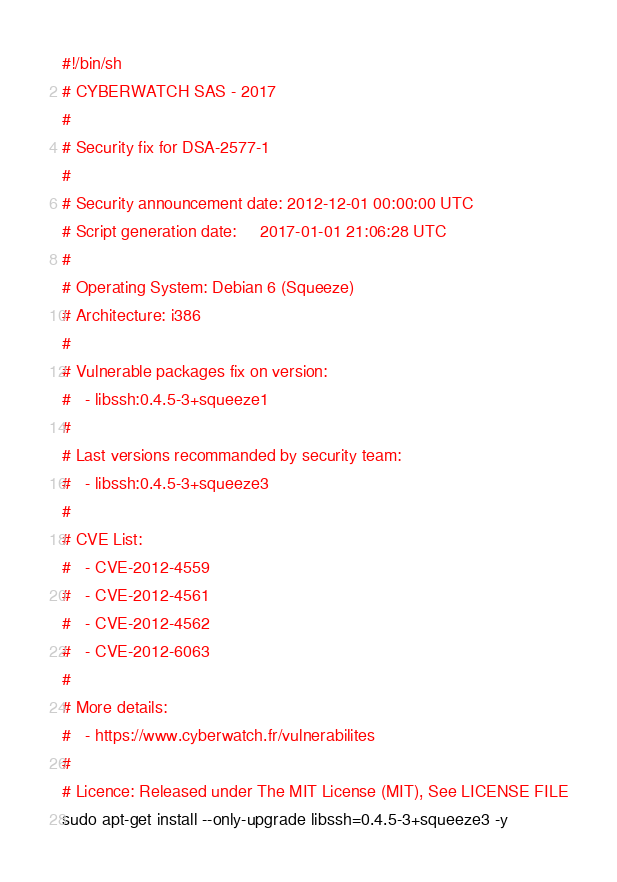<code> <loc_0><loc_0><loc_500><loc_500><_Bash_>#!/bin/sh
# CYBERWATCH SAS - 2017
#
# Security fix for DSA-2577-1
#
# Security announcement date: 2012-12-01 00:00:00 UTC
# Script generation date:     2017-01-01 21:06:28 UTC
#
# Operating System: Debian 6 (Squeeze)
# Architecture: i386
#
# Vulnerable packages fix on version:
#   - libssh:0.4.5-3+squeeze1
#
# Last versions recommanded by security team:
#   - libssh:0.4.5-3+squeeze3
#
# CVE List:
#   - CVE-2012-4559
#   - CVE-2012-4561
#   - CVE-2012-4562
#   - CVE-2012-6063
#
# More details:
#   - https://www.cyberwatch.fr/vulnerabilites
#
# Licence: Released under The MIT License (MIT), See LICENSE FILE
sudo apt-get install --only-upgrade libssh=0.4.5-3+squeeze3 -y
</code> 